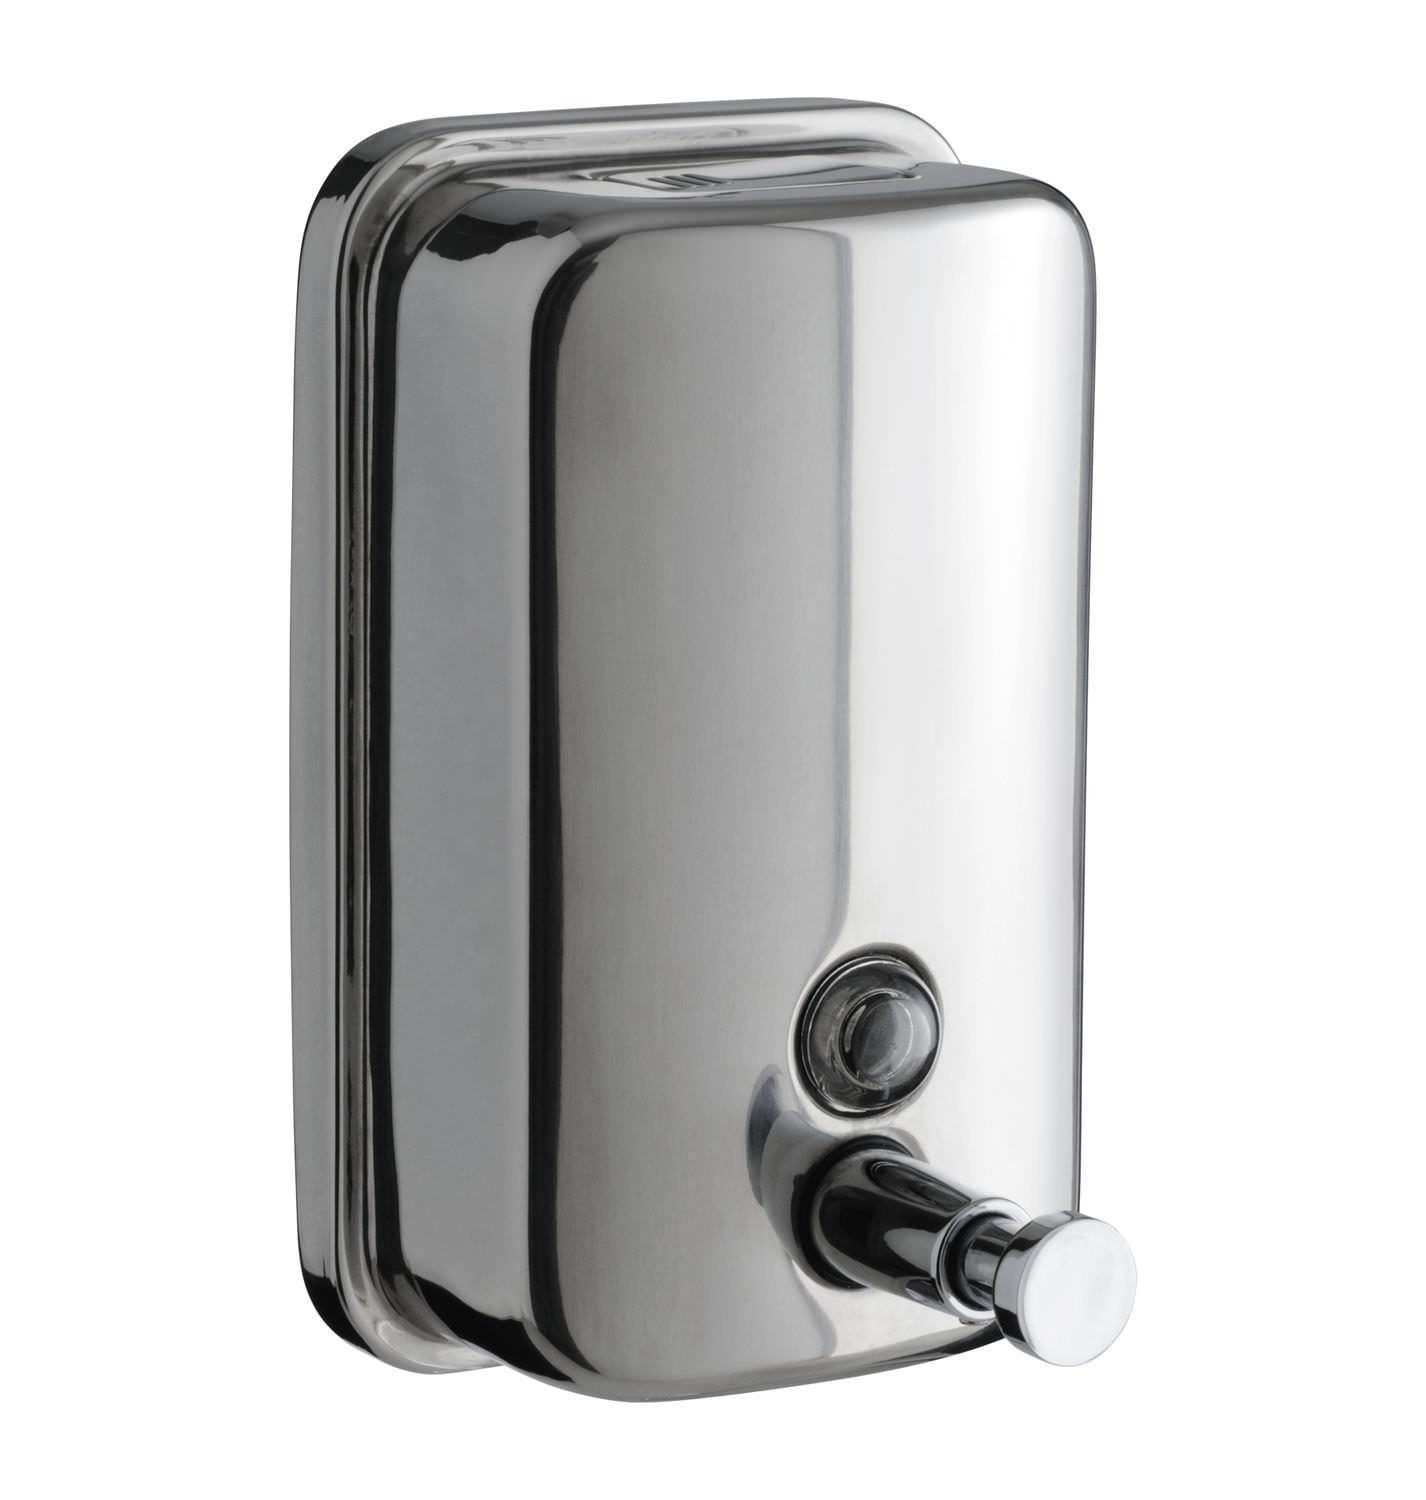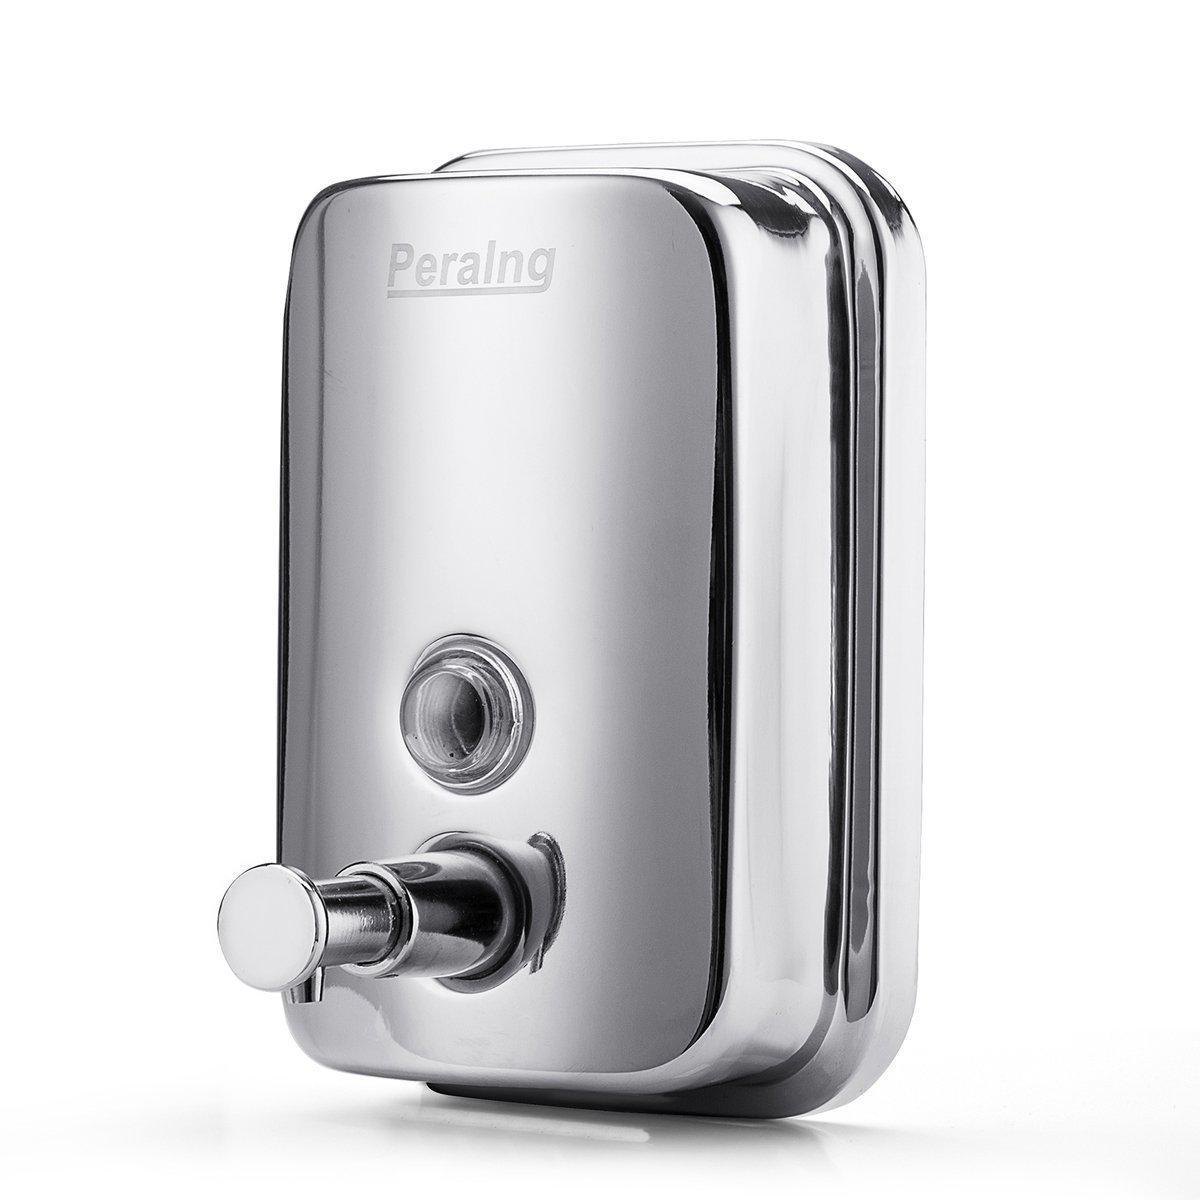The first image is the image on the left, the second image is the image on the right. Given the left and right images, does the statement "The dispenser in the image on the right has a round mounting bracket." hold true? Answer yes or no. No. 